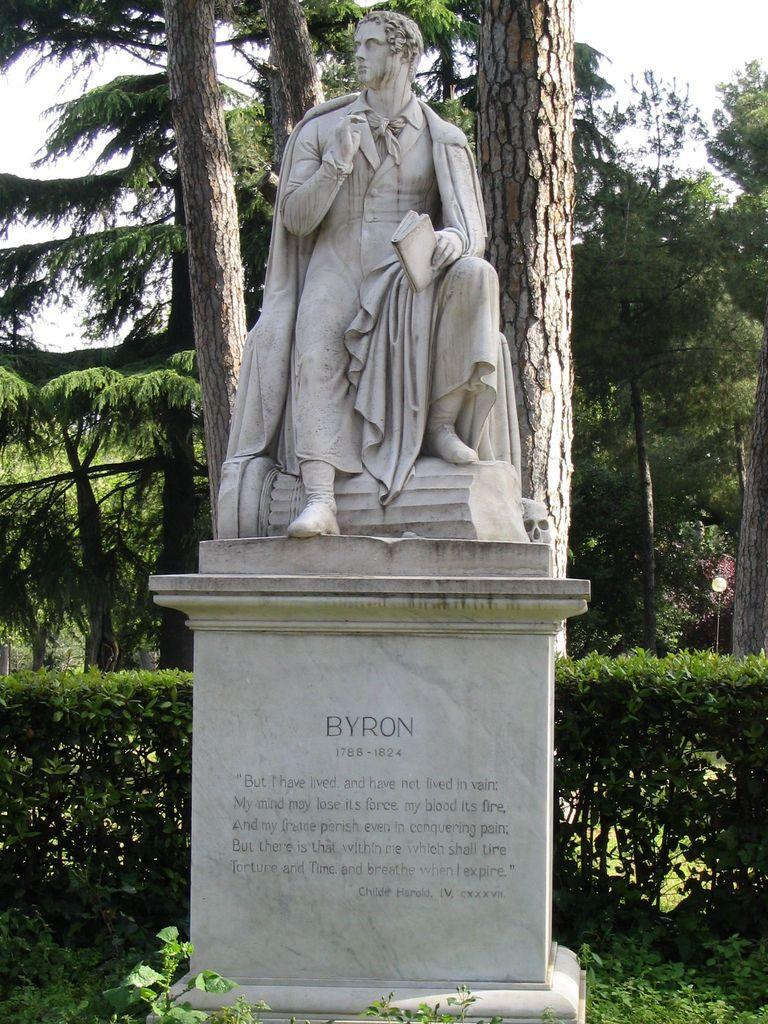What is the main subject located at the front of the image? There is a statue in the image, and it is at the front of the image. What can be seen in the background of the image? There are trees and the sky visible in the background of the image. What type of work is the statue doing in the image? The statue is not performing any work in the image, as it is a non-living object. What type of neck accessory is the statue wearing in the image? The statue does not have a neck or wear any neck accessory in the image. 